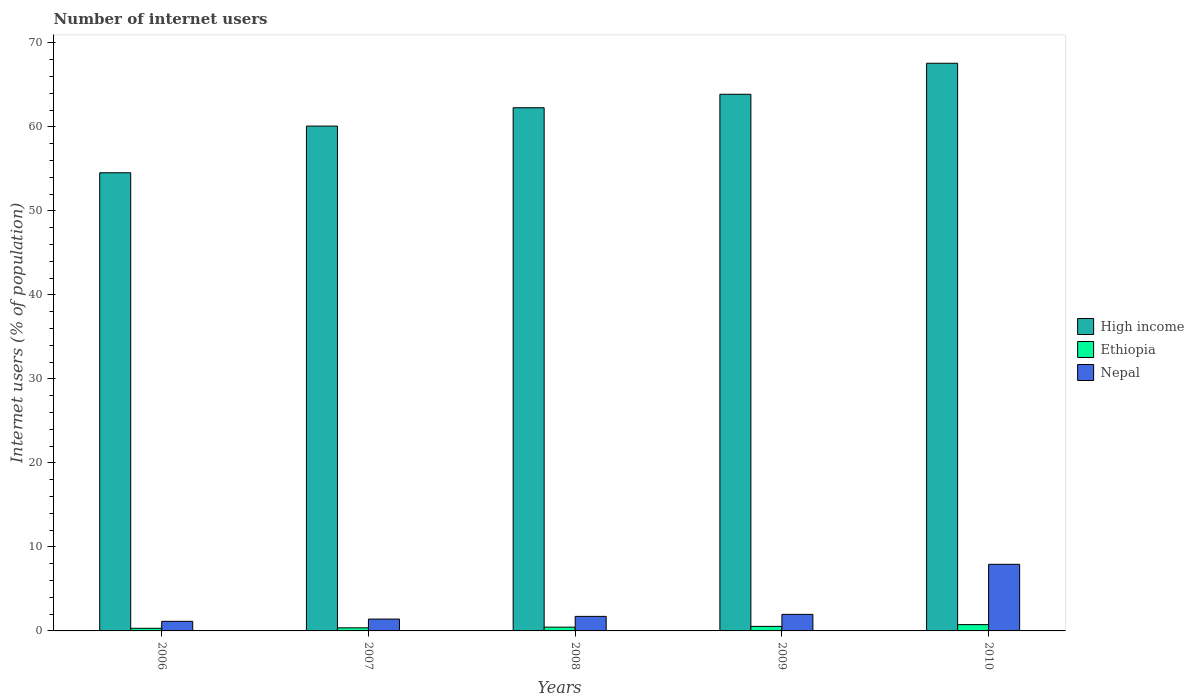Are the number of bars on each tick of the X-axis equal?
Provide a succinct answer. Yes. How many bars are there on the 1st tick from the left?
Give a very brief answer. 3. How many bars are there on the 2nd tick from the right?
Offer a terse response. 3. In how many cases, is the number of bars for a given year not equal to the number of legend labels?
Keep it short and to the point. 0. What is the number of internet users in Nepal in 2010?
Give a very brief answer. 7.93. Across all years, what is the maximum number of internet users in High income?
Provide a short and direct response. 67.57. Across all years, what is the minimum number of internet users in Ethiopia?
Offer a very short reply. 0.31. In which year was the number of internet users in Nepal maximum?
Make the answer very short. 2010. What is the total number of internet users in High income in the graph?
Offer a terse response. 308.37. What is the difference between the number of internet users in Ethiopia in 2008 and that in 2009?
Give a very brief answer. -0.09. What is the difference between the number of internet users in High income in 2007 and the number of internet users in Nepal in 2006?
Offer a terse response. 58.95. What is the average number of internet users in Nepal per year?
Offer a terse response. 2.84. In the year 2009, what is the difference between the number of internet users in Nepal and number of internet users in High income?
Provide a short and direct response. -61.91. In how many years, is the number of internet users in High income greater than 36 %?
Your answer should be compact. 5. What is the ratio of the number of internet users in Nepal in 2006 to that in 2010?
Ensure brevity in your answer.  0.14. What is the difference between the highest and the second highest number of internet users in Nepal?
Your answer should be very brief. 5.96. What is the difference between the highest and the lowest number of internet users in Nepal?
Offer a terse response. 6.79. In how many years, is the number of internet users in High income greater than the average number of internet users in High income taken over all years?
Your response must be concise. 3. Is the sum of the number of internet users in Ethiopia in 2007 and 2009 greater than the maximum number of internet users in High income across all years?
Your answer should be compact. No. What does the 3rd bar from the left in 2008 represents?
Provide a succinct answer. Nepal. What does the 1st bar from the right in 2009 represents?
Offer a terse response. Nepal. How many bars are there?
Provide a succinct answer. 15. What is the difference between two consecutive major ticks on the Y-axis?
Provide a short and direct response. 10. Are the values on the major ticks of Y-axis written in scientific E-notation?
Offer a terse response. No. Does the graph contain any zero values?
Give a very brief answer. No. Where does the legend appear in the graph?
Offer a terse response. Center right. What is the title of the graph?
Provide a succinct answer. Number of internet users. Does "Bolivia" appear as one of the legend labels in the graph?
Provide a short and direct response. No. What is the label or title of the X-axis?
Provide a succinct answer. Years. What is the label or title of the Y-axis?
Keep it short and to the point. Internet users (% of population). What is the Internet users (% of population) of High income in 2006?
Provide a short and direct response. 54.54. What is the Internet users (% of population) in Ethiopia in 2006?
Give a very brief answer. 0.31. What is the Internet users (% of population) in Nepal in 2006?
Offer a very short reply. 1.14. What is the Internet users (% of population) of High income in 2007?
Your answer should be very brief. 60.09. What is the Internet users (% of population) in Ethiopia in 2007?
Your answer should be compact. 0.37. What is the Internet users (% of population) in Nepal in 2007?
Keep it short and to the point. 1.41. What is the Internet users (% of population) of High income in 2008?
Give a very brief answer. 62.28. What is the Internet users (% of population) of Ethiopia in 2008?
Offer a very short reply. 0.45. What is the Internet users (% of population) of Nepal in 2008?
Your response must be concise. 1.73. What is the Internet users (% of population) of High income in 2009?
Your response must be concise. 63.88. What is the Internet users (% of population) of Ethiopia in 2009?
Your response must be concise. 0.54. What is the Internet users (% of population) in Nepal in 2009?
Provide a succinct answer. 1.97. What is the Internet users (% of population) in High income in 2010?
Your response must be concise. 67.57. What is the Internet users (% of population) in Nepal in 2010?
Ensure brevity in your answer.  7.93. Across all years, what is the maximum Internet users (% of population) of High income?
Offer a very short reply. 67.57. Across all years, what is the maximum Internet users (% of population) of Ethiopia?
Make the answer very short. 0.75. Across all years, what is the maximum Internet users (% of population) in Nepal?
Keep it short and to the point. 7.93. Across all years, what is the minimum Internet users (% of population) in High income?
Keep it short and to the point. 54.54. Across all years, what is the minimum Internet users (% of population) of Ethiopia?
Give a very brief answer. 0.31. Across all years, what is the minimum Internet users (% of population) of Nepal?
Ensure brevity in your answer.  1.14. What is the total Internet users (% of population) of High income in the graph?
Offer a terse response. 308.37. What is the total Internet users (% of population) in Ethiopia in the graph?
Your answer should be compact. 2.42. What is the total Internet users (% of population) of Nepal in the graph?
Ensure brevity in your answer.  14.18. What is the difference between the Internet users (% of population) in High income in 2006 and that in 2007?
Make the answer very short. -5.55. What is the difference between the Internet users (% of population) in Ethiopia in 2006 and that in 2007?
Give a very brief answer. -0.06. What is the difference between the Internet users (% of population) of Nepal in 2006 and that in 2007?
Give a very brief answer. -0.27. What is the difference between the Internet users (% of population) of High income in 2006 and that in 2008?
Provide a short and direct response. -7.74. What is the difference between the Internet users (% of population) in Ethiopia in 2006 and that in 2008?
Provide a short and direct response. -0.14. What is the difference between the Internet users (% of population) of Nepal in 2006 and that in 2008?
Provide a short and direct response. -0.59. What is the difference between the Internet users (% of population) in High income in 2006 and that in 2009?
Offer a terse response. -9.34. What is the difference between the Internet users (% of population) in Ethiopia in 2006 and that in 2009?
Offer a terse response. -0.23. What is the difference between the Internet users (% of population) in Nepal in 2006 and that in 2009?
Your answer should be compact. -0.83. What is the difference between the Internet users (% of population) of High income in 2006 and that in 2010?
Your answer should be very brief. -13.03. What is the difference between the Internet users (% of population) in Ethiopia in 2006 and that in 2010?
Ensure brevity in your answer.  -0.44. What is the difference between the Internet users (% of population) of Nepal in 2006 and that in 2010?
Give a very brief answer. -6.79. What is the difference between the Internet users (% of population) of High income in 2007 and that in 2008?
Offer a terse response. -2.18. What is the difference between the Internet users (% of population) of Ethiopia in 2007 and that in 2008?
Provide a short and direct response. -0.08. What is the difference between the Internet users (% of population) in Nepal in 2007 and that in 2008?
Give a very brief answer. -0.32. What is the difference between the Internet users (% of population) of High income in 2007 and that in 2009?
Provide a succinct answer. -3.79. What is the difference between the Internet users (% of population) in Ethiopia in 2007 and that in 2009?
Ensure brevity in your answer.  -0.17. What is the difference between the Internet users (% of population) of Nepal in 2007 and that in 2009?
Offer a terse response. -0.56. What is the difference between the Internet users (% of population) of High income in 2007 and that in 2010?
Your response must be concise. -7.48. What is the difference between the Internet users (% of population) in Ethiopia in 2007 and that in 2010?
Your response must be concise. -0.38. What is the difference between the Internet users (% of population) of Nepal in 2007 and that in 2010?
Give a very brief answer. -6.52. What is the difference between the Internet users (% of population) of High income in 2008 and that in 2009?
Your response must be concise. -1.6. What is the difference between the Internet users (% of population) in Ethiopia in 2008 and that in 2009?
Provide a short and direct response. -0.09. What is the difference between the Internet users (% of population) of Nepal in 2008 and that in 2009?
Offer a very short reply. -0.24. What is the difference between the Internet users (% of population) of High income in 2008 and that in 2010?
Provide a short and direct response. -5.3. What is the difference between the Internet users (% of population) in Nepal in 2008 and that in 2010?
Provide a succinct answer. -6.2. What is the difference between the Internet users (% of population) in High income in 2009 and that in 2010?
Make the answer very short. -3.69. What is the difference between the Internet users (% of population) of Ethiopia in 2009 and that in 2010?
Your answer should be compact. -0.21. What is the difference between the Internet users (% of population) of Nepal in 2009 and that in 2010?
Your answer should be compact. -5.96. What is the difference between the Internet users (% of population) of High income in 2006 and the Internet users (% of population) of Ethiopia in 2007?
Ensure brevity in your answer.  54.17. What is the difference between the Internet users (% of population) in High income in 2006 and the Internet users (% of population) in Nepal in 2007?
Your answer should be compact. 53.13. What is the difference between the Internet users (% of population) in Ethiopia in 2006 and the Internet users (% of population) in Nepal in 2007?
Provide a short and direct response. -1.1. What is the difference between the Internet users (% of population) of High income in 2006 and the Internet users (% of population) of Ethiopia in 2008?
Give a very brief answer. 54.09. What is the difference between the Internet users (% of population) in High income in 2006 and the Internet users (% of population) in Nepal in 2008?
Offer a terse response. 52.81. What is the difference between the Internet users (% of population) of Ethiopia in 2006 and the Internet users (% of population) of Nepal in 2008?
Offer a terse response. -1.42. What is the difference between the Internet users (% of population) in High income in 2006 and the Internet users (% of population) in Nepal in 2009?
Ensure brevity in your answer.  52.57. What is the difference between the Internet users (% of population) in Ethiopia in 2006 and the Internet users (% of population) in Nepal in 2009?
Offer a terse response. -1.66. What is the difference between the Internet users (% of population) in High income in 2006 and the Internet users (% of population) in Ethiopia in 2010?
Ensure brevity in your answer.  53.79. What is the difference between the Internet users (% of population) in High income in 2006 and the Internet users (% of population) in Nepal in 2010?
Keep it short and to the point. 46.61. What is the difference between the Internet users (% of population) of Ethiopia in 2006 and the Internet users (% of population) of Nepal in 2010?
Offer a terse response. -7.62. What is the difference between the Internet users (% of population) of High income in 2007 and the Internet users (% of population) of Ethiopia in 2008?
Offer a terse response. 59.65. What is the difference between the Internet users (% of population) of High income in 2007 and the Internet users (% of population) of Nepal in 2008?
Make the answer very short. 58.37. What is the difference between the Internet users (% of population) in Ethiopia in 2007 and the Internet users (% of population) in Nepal in 2008?
Your answer should be very brief. -1.36. What is the difference between the Internet users (% of population) of High income in 2007 and the Internet users (% of population) of Ethiopia in 2009?
Give a very brief answer. 59.55. What is the difference between the Internet users (% of population) in High income in 2007 and the Internet users (% of population) in Nepal in 2009?
Your response must be concise. 58.12. What is the difference between the Internet users (% of population) of High income in 2007 and the Internet users (% of population) of Ethiopia in 2010?
Offer a very short reply. 59.34. What is the difference between the Internet users (% of population) of High income in 2007 and the Internet users (% of population) of Nepal in 2010?
Make the answer very short. 52.16. What is the difference between the Internet users (% of population) of Ethiopia in 2007 and the Internet users (% of population) of Nepal in 2010?
Provide a short and direct response. -7.56. What is the difference between the Internet users (% of population) in High income in 2008 and the Internet users (% of population) in Ethiopia in 2009?
Your answer should be very brief. 61.74. What is the difference between the Internet users (% of population) of High income in 2008 and the Internet users (% of population) of Nepal in 2009?
Your answer should be compact. 60.31. What is the difference between the Internet users (% of population) in Ethiopia in 2008 and the Internet users (% of population) in Nepal in 2009?
Provide a succinct answer. -1.52. What is the difference between the Internet users (% of population) in High income in 2008 and the Internet users (% of population) in Ethiopia in 2010?
Your response must be concise. 61.53. What is the difference between the Internet users (% of population) in High income in 2008 and the Internet users (% of population) in Nepal in 2010?
Your answer should be compact. 54.35. What is the difference between the Internet users (% of population) of Ethiopia in 2008 and the Internet users (% of population) of Nepal in 2010?
Keep it short and to the point. -7.48. What is the difference between the Internet users (% of population) of High income in 2009 and the Internet users (% of population) of Ethiopia in 2010?
Provide a short and direct response. 63.13. What is the difference between the Internet users (% of population) of High income in 2009 and the Internet users (% of population) of Nepal in 2010?
Give a very brief answer. 55.95. What is the difference between the Internet users (% of population) in Ethiopia in 2009 and the Internet users (% of population) in Nepal in 2010?
Your answer should be compact. -7.39. What is the average Internet users (% of population) of High income per year?
Your answer should be very brief. 61.67. What is the average Internet users (% of population) in Ethiopia per year?
Keep it short and to the point. 0.48. What is the average Internet users (% of population) in Nepal per year?
Your answer should be compact. 2.84. In the year 2006, what is the difference between the Internet users (% of population) of High income and Internet users (% of population) of Ethiopia?
Provide a succinct answer. 54.23. In the year 2006, what is the difference between the Internet users (% of population) in High income and Internet users (% of population) in Nepal?
Provide a short and direct response. 53.4. In the year 2006, what is the difference between the Internet users (% of population) of Ethiopia and Internet users (% of population) of Nepal?
Provide a succinct answer. -0.83. In the year 2007, what is the difference between the Internet users (% of population) of High income and Internet users (% of population) of Ethiopia?
Provide a short and direct response. 59.73. In the year 2007, what is the difference between the Internet users (% of population) of High income and Internet users (% of population) of Nepal?
Make the answer very short. 58.69. In the year 2007, what is the difference between the Internet users (% of population) in Ethiopia and Internet users (% of population) in Nepal?
Offer a terse response. -1.04. In the year 2008, what is the difference between the Internet users (% of population) in High income and Internet users (% of population) in Ethiopia?
Keep it short and to the point. 61.83. In the year 2008, what is the difference between the Internet users (% of population) in High income and Internet users (% of population) in Nepal?
Keep it short and to the point. 60.55. In the year 2008, what is the difference between the Internet users (% of population) of Ethiopia and Internet users (% of population) of Nepal?
Offer a very short reply. -1.28. In the year 2009, what is the difference between the Internet users (% of population) in High income and Internet users (% of population) in Ethiopia?
Your answer should be very brief. 63.34. In the year 2009, what is the difference between the Internet users (% of population) of High income and Internet users (% of population) of Nepal?
Your response must be concise. 61.91. In the year 2009, what is the difference between the Internet users (% of population) in Ethiopia and Internet users (% of population) in Nepal?
Provide a succinct answer. -1.43. In the year 2010, what is the difference between the Internet users (% of population) of High income and Internet users (% of population) of Ethiopia?
Offer a terse response. 66.82. In the year 2010, what is the difference between the Internet users (% of population) in High income and Internet users (% of population) in Nepal?
Provide a short and direct response. 59.64. In the year 2010, what is the difference between the Internet users (% of population) of Ethiopia and Internet users (% of population) of Nepal?
Offer a terse response. -7.18. What is the ratio of the Internet users (% of population) of High income in 2006 to that in 2007?
Make the answer very short. 0.91. What is the ratio of the Internet users (% of population) in Ethiopia in 2006 to that in 2007?
Give a very brief answer. 0.84. What is the ratio of the Internet users (% of population) in Nepal in 2006 to that in 2007?
Your response must be concise. 0.81. What is the ratio of the Internet users (% of population) in High income in 2006 to that in 2008?
Give a very brief answer. 0.88. What is the ratio of the Internet users (% of population) in Ethiopia in 2006 to that in 2008?
Ensure brevity in your answer.  0.69. What is the ratio of the Internet users (% of population) in Nepal in 2006 to that in 2008?
Make the answer very short. 0.66. What is the ratio of the Internet users (% of population) of High income in 2006 to that in 2009?
Your answer should be very brief. 0.85. What is the ratio of the Internet users (% of population) of Ethiopia in 2006 to that in 2009?
Provide a succinct answer. 0.58. What is the ratio of the Internet users (% of population) of Nepal in 2006 to that in 2009?
Provide a succinct answer. 0.58. What is the ratio of the Internet users (% of population) of High income in 2006 to that in 2010?
Give a very brief answer. 0.81. What is the ratio of the Internet users (% of population) in Ethiopia in 2006 to that in 2010?
Provide a succinct answer. 0.41. What is the ratio of the Internet users (% of population) of Nepal in 2006 to that in 2010?
Make the answer very short. 0.14. What is the ratio of the Internet users (% of population) of High income in 2007 to that in 2008?
Make the answer very short. 0.96. What is the ratio of the Internet users (% of population) in Ethiopia in 2007 to that in 2008?
Make the answer very short. 0.82. What is the ratio of the Internet users (% of population) in Nepal in 2007 to that in 2008?
Your answer should be compact. 0.81. What is the ratio of the Internet users (% of population) in High income in 2007 to that in 2009?
Ensure brevity in your answer.  0.94. What is the ratio of the Internet users (% of population) in Ethiopia in 2007 to that in 2009?
Your response must be concise. 0.69. What is the ratio of the Internet users (% of population) of Nepal in 2007 to that in 2009?
Offer a terse response. 0.72. What is the ratio of the Internet users (% of population) of High income in 2007 to that in 2010?
Make the answer very short. 0.89. What is the ratio of the Internet users (% of population) in Ethiopia in 2007 to that in 2010?
Offer a very short reply. 0.49. What is the ratio of the Internet users (% of population) of Nepal in 2007 to that in 2010?
Keep it short and to the point. 0.18. What is the ratio of the Internet users (% of population) of High income in 2008 to that in 2009?
Your answer should be very brief. 0.97. What is the ratio of the Internet users (% of population) of Ethiopia in 2008 to that in 2009?
Your response must be concise. 0.83. What is the ratio of the Internet users (% of population) in Nepal in 2008 to that in 2009?
Your response must be concise. 0.88. What is the ratio of the Internet users (% of population) of High income in 2008 to that in 2010?
Keep it short and to the point. 0.92. What is the ratio of the Internet users (% of population) in Nepal in 2008 to that in 2010?
Ensure brevity in your answer.  0.22. What is the ratio of the Internet users (% of population) of High income in 2009 to that in 2010?
Offer a very short reply. 0.95. What is the ratio of the Internet users (% of population) in Ethiopia in 2009 to that in 2010?
Provide a succinct answer. 0.72. What is the ratio of the Internet users (% of population) in Nepal in 2009 to that in 2010?
Make the answer very short. 0.25. What is the difference between the highest and the second highest Internet users (% of population) in High income?
Provide a succinct answer. 3.69. What is the difference between the highest and the second highest Internet users (% of population) in Ethiopia?
Give a very brief answer. 0.21. What is the difference between the highest and the second highest Internet users (% of population) in Nepal?
Offer a terse response. 5.96. What is the difference between the highest and the lowest Internet users (% of population) in High income?
Offer a terse response. 13.03. What is the difference between the highest and the lowest Internet users (% of population) in Ethiopia?
Provide a succinct answer. 0.44. What is the difference between the highest and the lowest Internet users (% of population) in Nepal?
Make the answer very short. 6.79. 